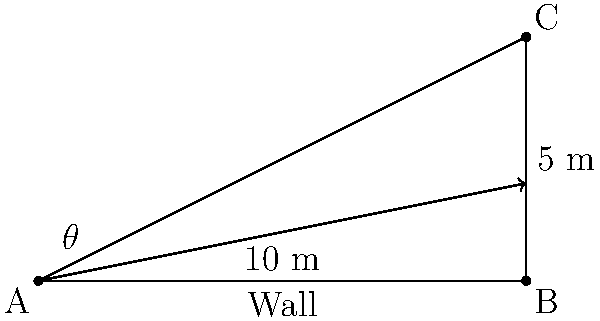A security camera needs to be installed on a wall at point C, which is 5 meters above the ground and 10 meters from point A. What is the angle of view ($\theta$) in degrees that the camera needs to cover to monitor the entire area from point A to point B? To solve this problem, we'll use trigonometry:

1. Identify the triangle: We have a right-angled triangle ABC.

2. Recognize the sides:
   - Adjacent side (AB) = 10 meters
   - Opposite side (BC) = 5 meters

3. Calculate the angle using the arctangent function:
   $$\theta = \arctan(\frac{\text{opposite}}{\text{adjacent}})$$
   $$\theta = \arctan(\frac{5}{10})$$
   $$\theta = \arctan(0.5)$$

4. Convert the result to degrees:
   $$\theta \approx 26.57^\circ$$

5. The camera needs to cover the angle from the horizontal to this calculated angle.

Therefore, the angle of view ($\theta$) that the camera needs to cover is approximately 26.57°.
Answer: 26.57° 